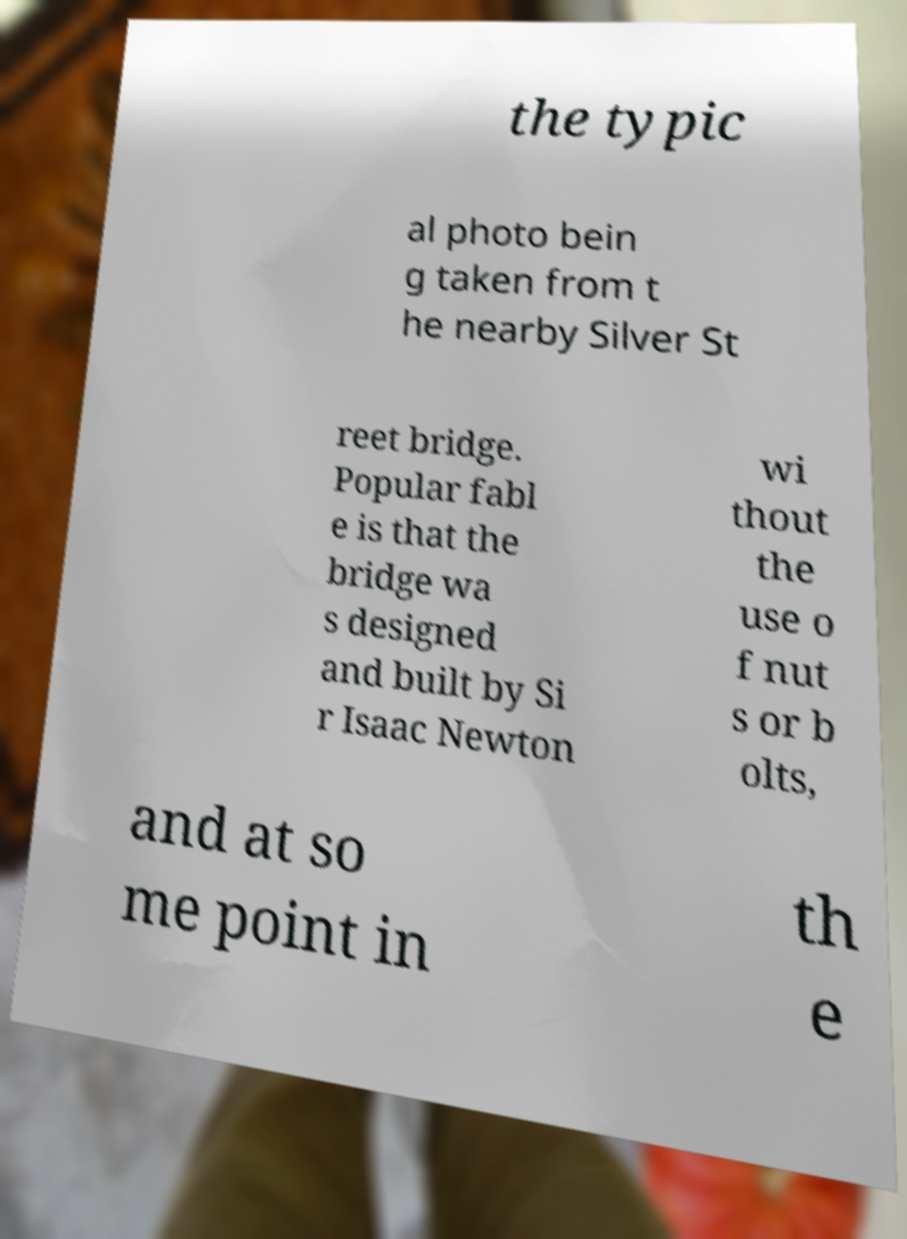What messages or text are displayed in this image? I need them in a readable, typed format. the typic al photo bein g taken from t he nearby Silver St reet bridge. Popular fabl e is that the bridge wa s designed and built by Si r Isaac Newton wi thout the use o f nut s or b olts, and at so me point in th e 